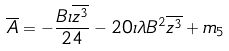<formula> <loc_0><loc_0><loc_500><loc_500>\overline { A } = - \frac { B \iota \overline { z ^ { 3 } } } { 2 4 } - 2 0 \iota \lambda B ^ { 2 } \overline { z ^ { 3 } } + m _ { 5 }</formula> 